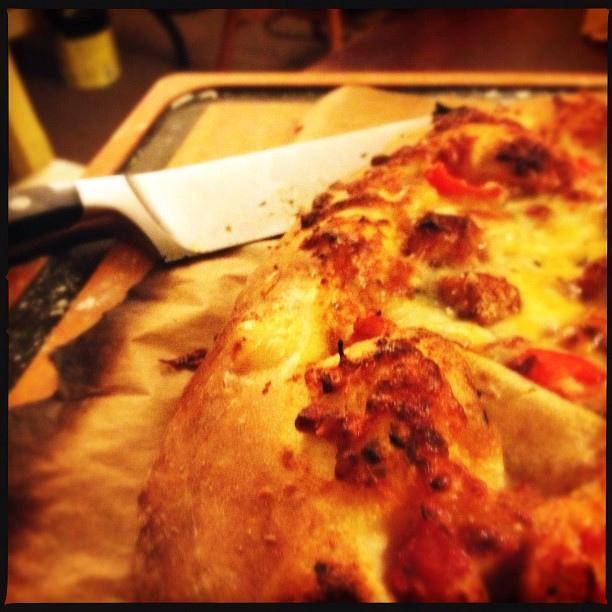How many adult horses are there?
Give a very brief answer. 0. 